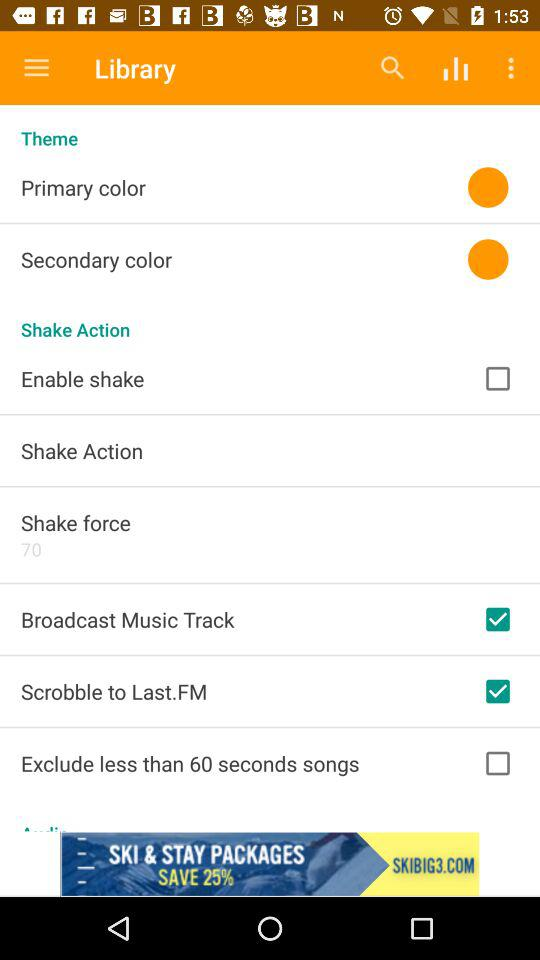What is the status of the broadcast music track setting? The status is on. 